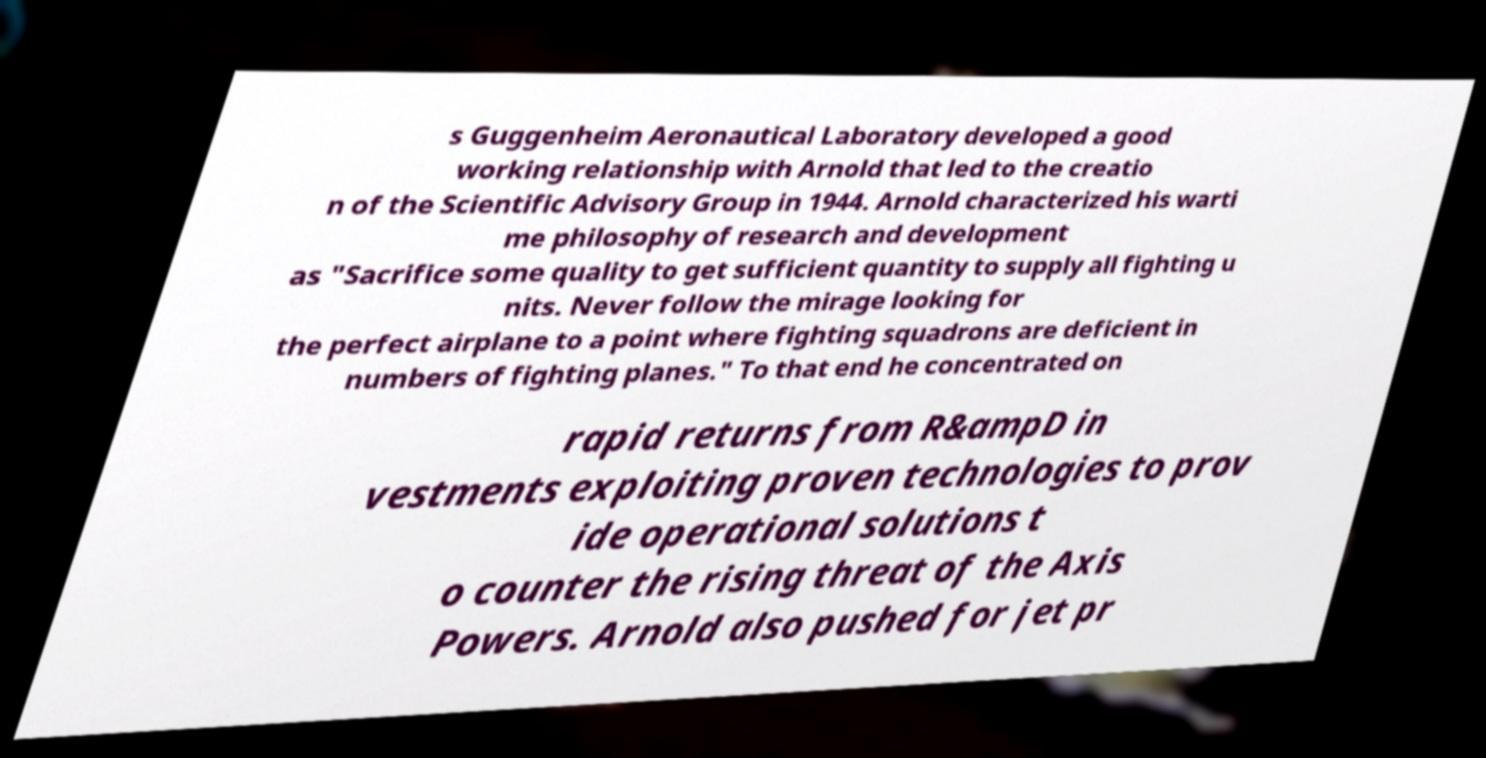For documentation purposes, I need the text within this image transcribed. Could you provide that? s Guggenheim Aeronautical Laboratory developed a good working relationship with Arnold that led to the creatio n of the Scientific Advisory Group in 1944. Arnold characterized his warti me philosophy of research and development as "Sacrifice some quality to get sufficient quantity to supply all fighting u nits. Never follow the mirage looking for the perfect airplane to a point where fighting squadrons are deficient in numbers of fighting planes." To that end he concentrated on rapid returns from R&ampD in vestments exploiting proven technologies to prov ide operational solutions t o counter the rising threat of the Axis Powers. Arnold also pushed for jet pr 